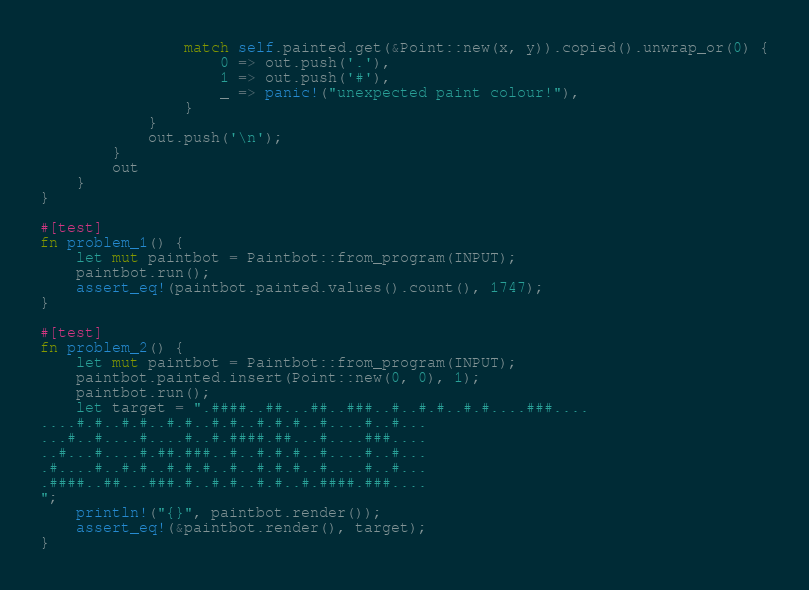<code> <loc_0><loc_0><loc_500><loc_500><_Rust_>                match self.painted.get(&Point::new(x, y)).copied().unwrap_or(0) {
                    0 => out.push('.'),
                    1 => out.push('#'),
                    _ => panic!("unexpected paint colour!"),
                }
            }
            out.push('\n');
        }
        out
    }
}

#[test]
fn problem_1() {
    let mut paintbot = Paintbot::from_program(INPUT);
    paintbot.run();
    assert_eq!(paintbot.painted.values().count(), 1747);
}

#[test]
fn problem_2() {
    let mut paintbot = Paintbot::from_program(INPUT);
    paintbot.painted.insert(Point::new(0, 0), 1);
    paintbot.run();
    let target = ".####..##...##..###..#..#.#..#.#....###....
....#.#..#.#..#.#..#.#..#.#.#..#....#..#...
...#..#....#....#..#.####.##...#....###....
..#...#....#.##.###..#..#.#.#..#....#..#...
.#....#..#.#..#.#.#..#..#.#.#..#....#..#...
.####..##...###.#..#.#..#.#..#.####.###....
";
    println!("{}", paintbot.render());
    assert_eq!(&paintbot.render(), target);
}
</code> 